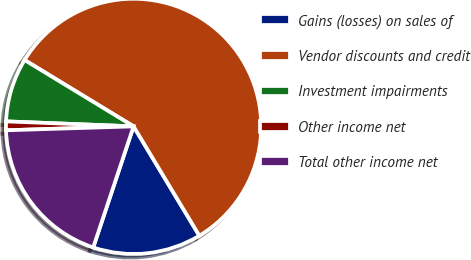Convert chart to OTSL. <chart><loc_0><loc_0><loc_500><loc_500><pie_chart><fcel>Gains (losses) on sales of<fcel>Vendor discounts and credit<fcel>Investment impairments<fcel>Other income net<fcel>Total other income net<nl><fcel>13.74%<fcel>57.68%<fcel>8.08%<fcel>1.11%<fcel>19.39%<nl></chart> 